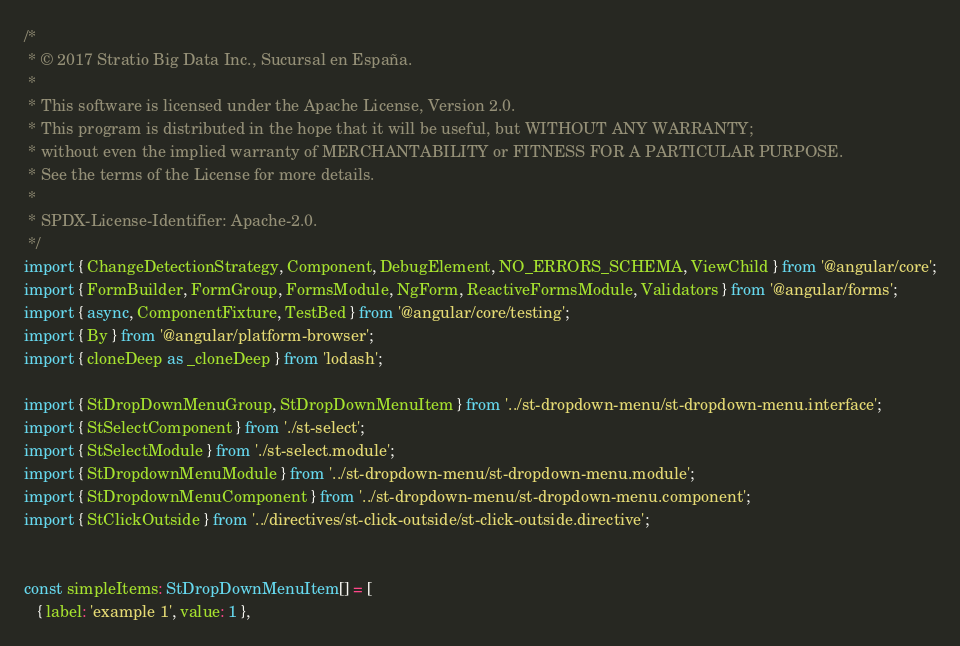<code> <loc_0><loc_0><loc_500><loc_500><_TypeScript_>/*
 * © 2017 Stratio Big Data Inc., Sucursal en España.
 *
 * This software is licensed under the Apache License, Version 2.0.
 * This program is distributed in the hope that it will be useful, but WITHOUT ANY WARRANTY;
 * without even the implied warranty of MERCHANTABILITY or FITNESS FOR A PARTICULAR PURPOSE.
 * See the terms of the License for more details.
 *
 * SPDX-License-Identifier: Apache-2.0.
 */
import { ChangeDetectionStrategy, Component, DebugElement, NO_ERRORS_SCHEMA, ViewChild } from '@angular/core';
import { FormBuilder, FormGroup, FormsModule, NgForm, ReactiveFormsModule, Validators } from '@angular/forms';
import { async, ComponentFixture, TestBed } from '@angular/core/testing';
import { By } from '@angular/platform-browser';
import { cloneDeep as _cloneDeep } from 'lodash';

import { StDropDownMenuGroup, StDropDownMenuItem } from '../st-dropdown-menu/st-dropdown-menu.interface';
import { StSelectComponent } from './st-select';
import { StSelectModule } from './st-select.module';
import { StDropdownMenuModule } from '../st-dropdown-menu/st-dropdown-menu.module';
import { StDropdownMenuComponent } from '../st-dropdown-menu/st-dropdown-menu.component';
import { StClickOutside } from '../directives/st-click-outside/st-click-outside.directive';


const simpleItems: StDropDownMenuItem[] = [
   { label: 'example 1', value: 1 },</code> 